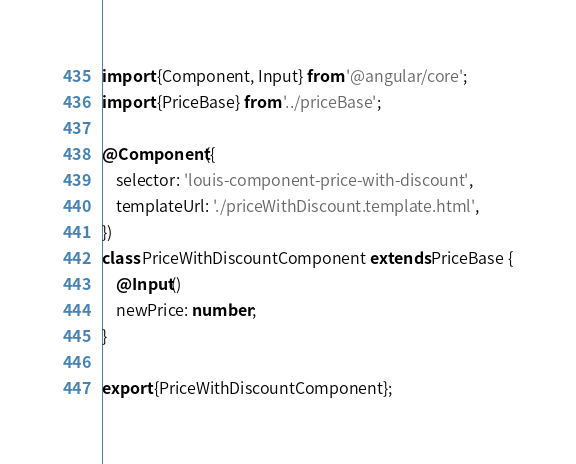Convert code to text. <code><loc_0><loc_0><loc_500><loc_500><_TypeScript_>import {Component, Input} from '@angular/core';
import {PriceBase} from '../priceBase';

@Component({
    selector: 'louis-component-price-with-discount',
    templateUrl: './priceWithDiscount.template.html',
})
class PriceWithDiscountComponent extends PriceBase {
    @Input()
    newPrice: number;
}

export {PriceWithDiscountComponent};
</code> 